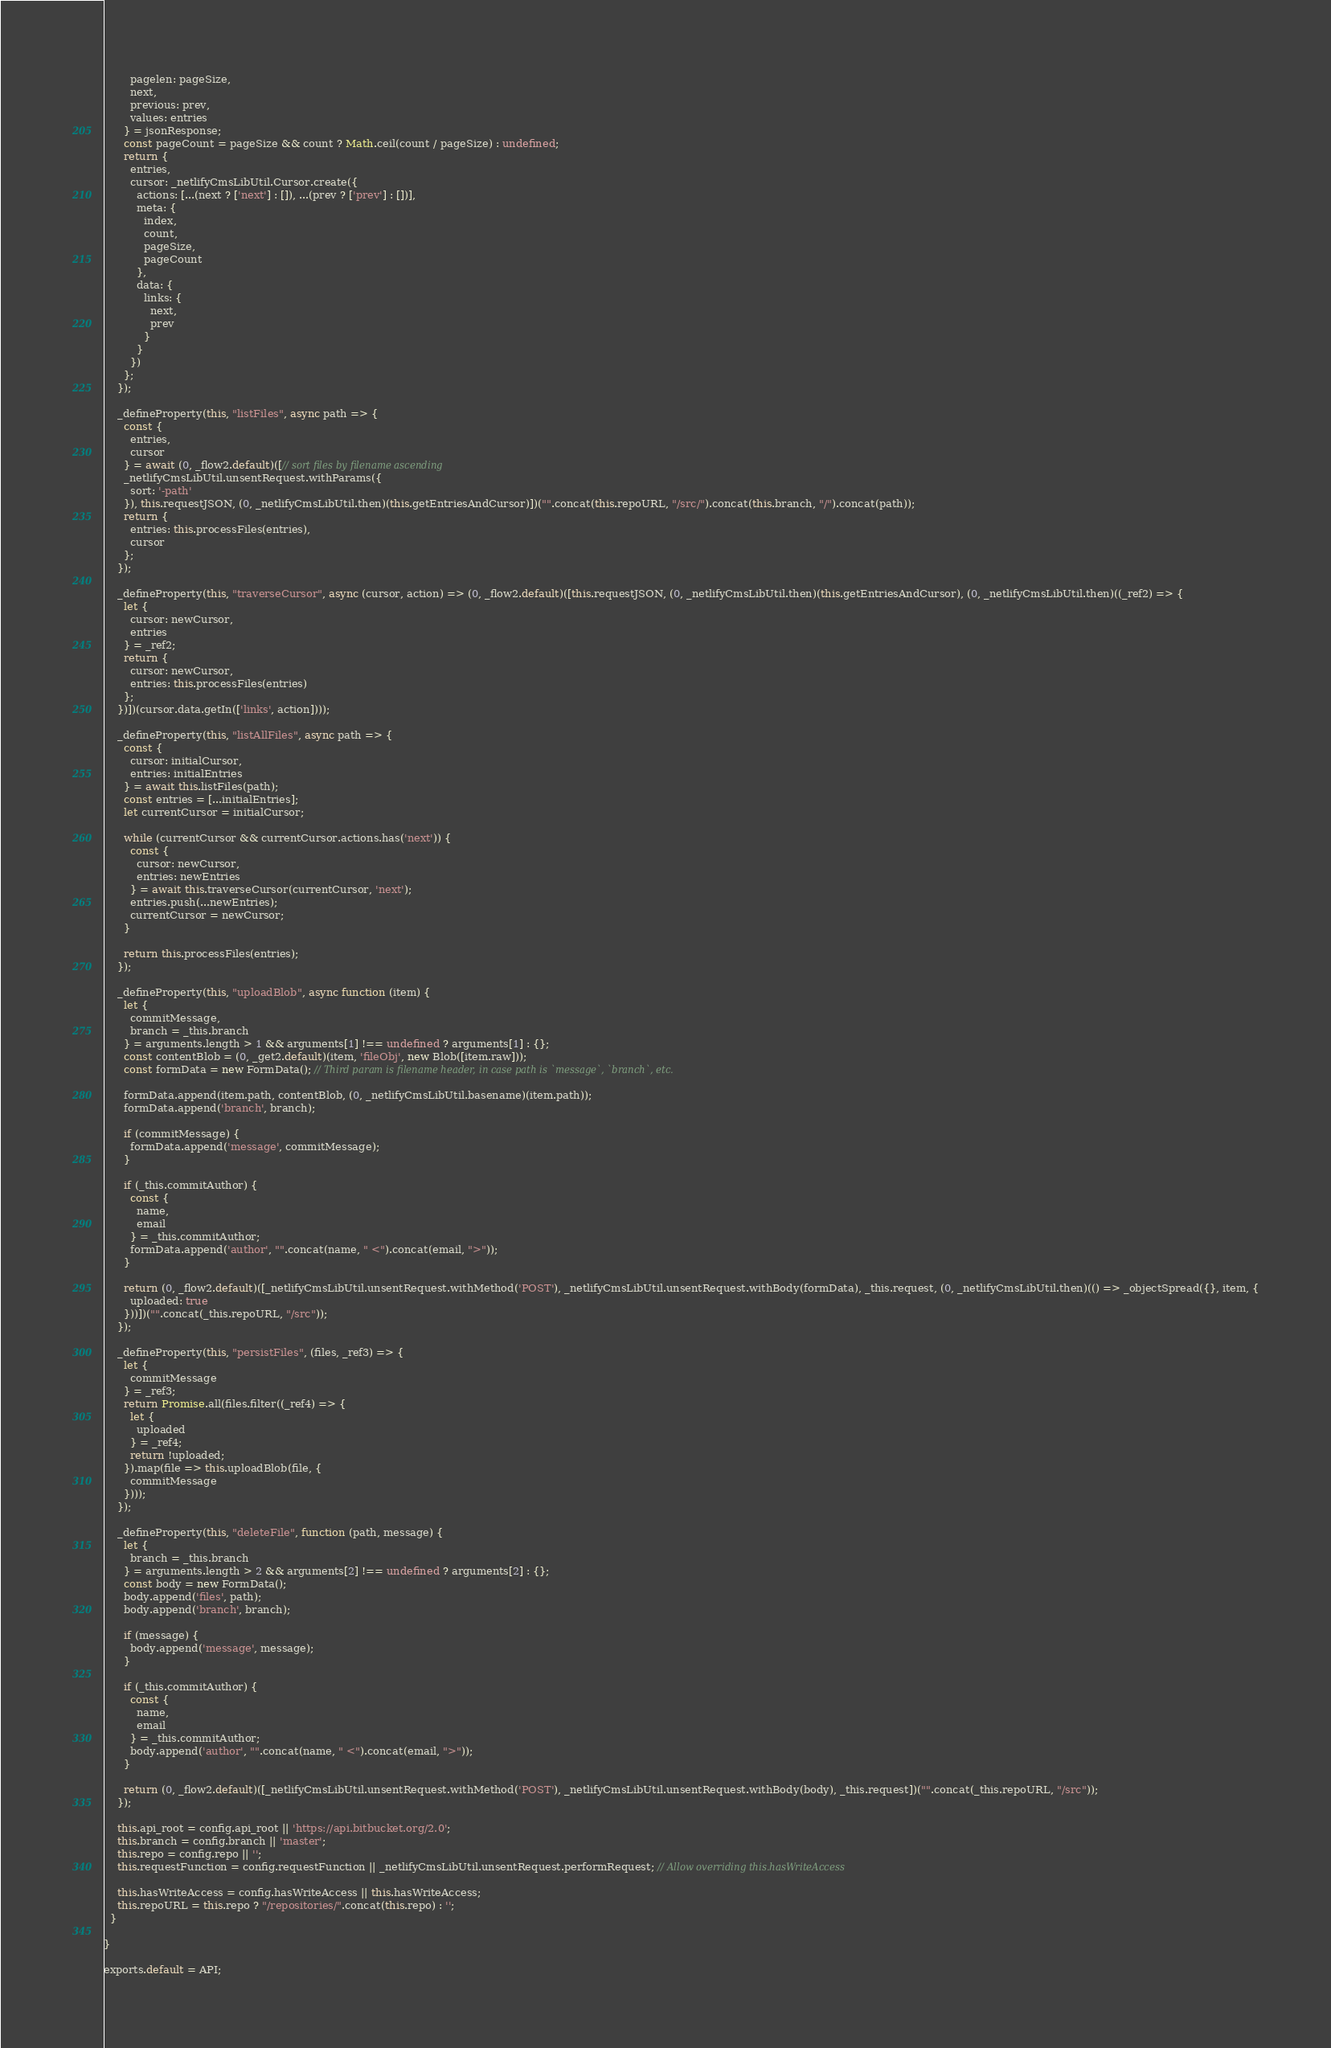Convert code to text. <code><loc_0><loc_0><loc_500><loc_500><_JavaScript_>        pagelen: pageSize,
        next,
        previous: prev,
        values: entries
      } = jsonResponse;
      const pageCount = pageSize && count ? Math.ceil(count / pageSize) : undefined;
      return {
        entries,
        cursor: _netlifyCmsLibUtil.Cursor.create({
          actions: [...(next ? ['next'] : []), ...(prev ? ['prev'] : [])],
          meta: {
            index,
            count,
            pageSize,
            pageCount
          },
          data: {
            links: {
              next,
              prev
            }
          }
        })
      };
    });

    _defineProperty(this, "listFiles", async path => {
      const {
        entries,
        cursor
      } = await (0, _flow2.default)([// sort files by filename ascending
      _netlifyCmsLibUtil.unsentRequest.withParams({
        sort: '-path'
      }), this.requestJSON, (0, _netlifyCmsLibUtil.then)(this.getEntriesAndCursor)])("".concat(this.repoURL, "/src/").concat(this.branch, "/").concat(path));
      return {
        entries: this.processFiles(entries),
        cursor
      };
    });

    _defineProperty(this, "traverseCursor", async (cursor, action) => (0, _flow2.default)([this.requestJSON, (0, _netlifyCmsLibUtil.then)(this.getEntriesAndCursor), (0, _netlifyCmsLibUtil.then)((_ref2) => {
      let {
        cursor: newCursor,
        entries
      } = _ref2;
      return {
        cursor: newCursor,
        entries: this.processFiles(entries)
      };
    })])(cursor.data.getIn(['links', action])));

    _defineProperty(this, "listAllFiles", async path => {
      const {
        cursor: initialCursor,
        entries: initialEntries
      } = await this.listFiles(path);
      const entries = [...initialEntries];
      let currentCursor = initialCursor;

      while (currentCursor && currentCursor.actions.has('next')) {
        const {
          cursor: newCursor,
          entries: newEntries
        } = await this.traverseCursor(currentCursor, 'next');
        entries.push(...newEntries);
        currentCursor = newCursor;
      }

      return this.processFiles(entries);
    });

    _defineProperty(this, "uploadBlob", async function (item) {
      let {
        commitMessage,
        branch = _this.branch
      } = arguments.length > 1 && arguments[1] !== undefined ? arguments[1] : {};
      const contentBlob = (0, _get2.default)(item, 'fileObj', new Blob([item.raw]));
      const formData = new FormData(); // Third param is filename header, in case path is `message`, `branch`, etc.

      formData.append(item.path, contentBlob, (0, _netlifyCmsLibUtil.basename)(item.path));
      formData.append('branch', branch);

      if (commitMessage) {
        formData.append('message', commitMessage);
      }

      if (_this.commitAuthor) {
        const {
          name,
          email
        } = _this.commitAuthor;
        formData.append('author', "".concat(name, " <").concat(email, ">"));
      }

      return (0, _flow2.default)([_netlifyCmsLibUtil.unsentRequest.withMethod('POST'), _netlifyCmsLibUtil.unsentRequest.withBody(formData), _this.request, (0, _netlifyCmsLibUtil.then)(() => _objectSpread({}, item, {
        uploaded: true
      }))])("".concat(_this.repoURL, "/src"));
    });

    _defineProperty(this, "persistFiles", (files, _ref3) => {
      let {
        commitMessage
      } = _ref3;
      return Promise.all(files.filter((_ref4) => {
        let {
          uploaded
        } = _ref4;
        return !uploaded;
      }).map(file => this.uploadBlob(file, {
        commitMessage
      })));
    });

    _defineProperty(this, "deleteFile", function (path, message) {
      let {
        branch = _this.branch
      } = arguments.length > 2 && arguments[2] !== undefined ? arguments[2] : {};
      const body = new FormData();
      body.append('files', path);
      body.append('branch', branch);

      if (message) {
        body.append('message', message);
      }

      if (_this.commitAuthor) {
        const {
          name,
          email
        } = _this.commitAuthor;
        body.append('author', "".concat(name, " <").concat(email, ">"));
      }

      return (0, _flow2.default)([_netlifyCmsLibUtil.unsentRequest.withMethod('POST'), _netlifyCmsLibUtil.unsentRequest.withBody(body), _this.request])("".concat(_this.repoURL, "/src"));
    });

    this.api_root = config.api_root || 'https://api.bitbucket.org/2.0';
    this.branch = config.branch || 'master';
    this.repo = config.repo || '';
    this.requestFunction = config.requestFunction || _netlifyCmsLibUtil.unsentRequest.performRequest; // Allow overriding this.hasWriteAccess

    this.hasWriteAccess = config.hasWriteAccess || this.hasWriteAccess;
    this.repoURL = this.repo ? "/repositories/".concat(this.repo) : '';
  }

}

exports.default = API;</code> 